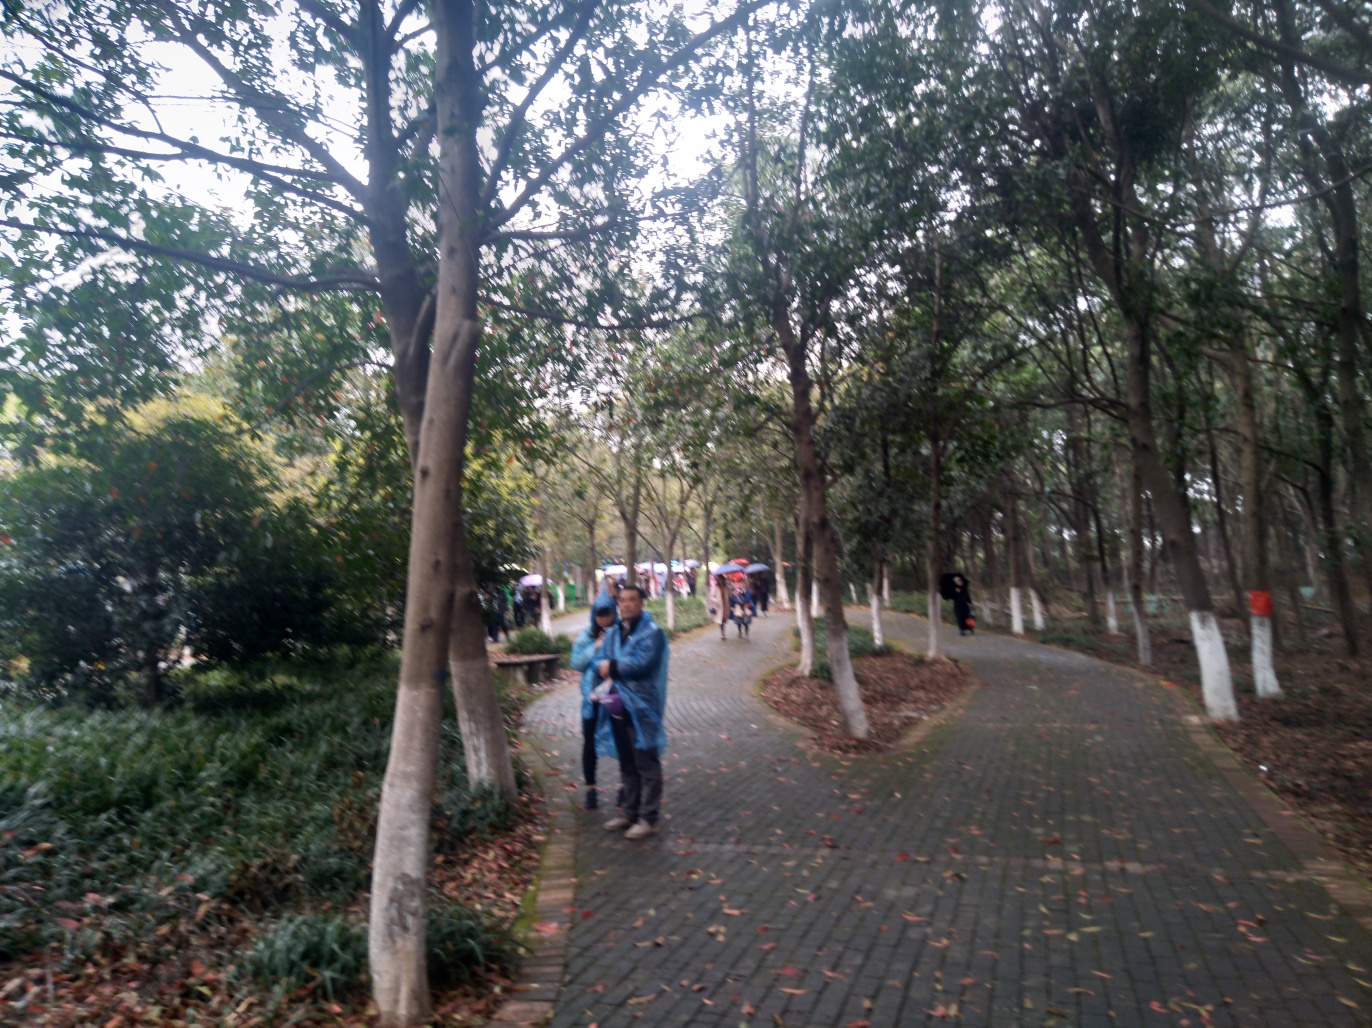Can you tell me anything about the season or the climate of this location? While it's not possible to determine the precise season or climate with certainty from this single image, certain clues can provide hints. The attire of the people suggests it's not particularly hot or cold, indicating a temperate climate or a transitional season like spring or autumn. The overcast sky and lack of foliage on some trees could mean it's either fall, with leaves having dropped, or early spring, when trees have not yet fully budded. The green foliage and the absence of snow or people dressed in warm clothing further suggest that it's not winter. 